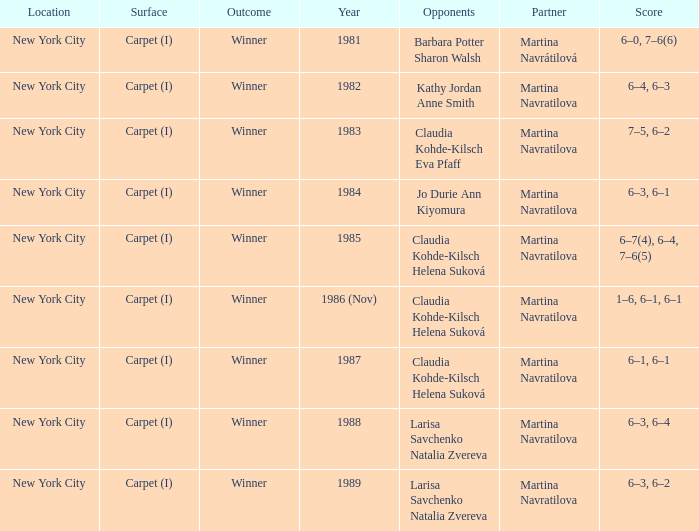Parse the table in full. {'header': ['Location', 'Surface', 'Outcome', 'Year', 'Opponents', 'Partner', 'Score'], 'rows': [['New York City', 'Carpet (I)', 'Winner', '1981', 'Barbara Potter Sharon Walsh', 'Martina Navrátilová', '6–0, 7–6(6)'], ['New York City', 'Carpet (I)', 'Winner', '1982', 'Kathy Jordan Anne Smith', 'Martina Navratilova', '6–4, 6–3'], ['New York City', 'Carpet (I)', 'Winner', '1983', 'Claudia Kohde-Kilsch Eva Pfaff', 'Martina Navratilova', '7–5, 6–2'], ['New York City', 'Carpet (I)', 'Winner', '1984', 'Jo Durie Ann Kiyomura', 'Martina Navratilova', '6–3, 6–1'], ['New York City', 'Carpet (I)', 'Winner', '1985', 'Claudia Kohde-Kilsch Helena Suková', 'Martina Navratilova', '6–7(4), 6–4, 7–6(5)'], ['New York City', 'Carpet (I)', 'Winner', '1986 (Nov)', 'Claudia Kohde-Kilsch Helena Suková', 'Martina Navratilova', '1–6, 6–1, 6–1'], ['New York City', 'Carpet (I)', 'Winner', '1987', 'Claudia Kohde-Kilsch Helena Suková', 'Martina Navratilova', '6–1, 6–1'], ['New York City', 'Carpet (I)', 'Winner', '1988', 'Larisa Savchenko Natalia Zvereva', 'Martina Navratilova', '6–3, 6–4'], ['New York City', 'Carpet (I)', 'Winner', '1989', 'Larisa Savchenko Natalia Zvereva', 'Martina Navratilova', '6–3, 6–2']]} What was the outcome for the match in 1989? Winner. 